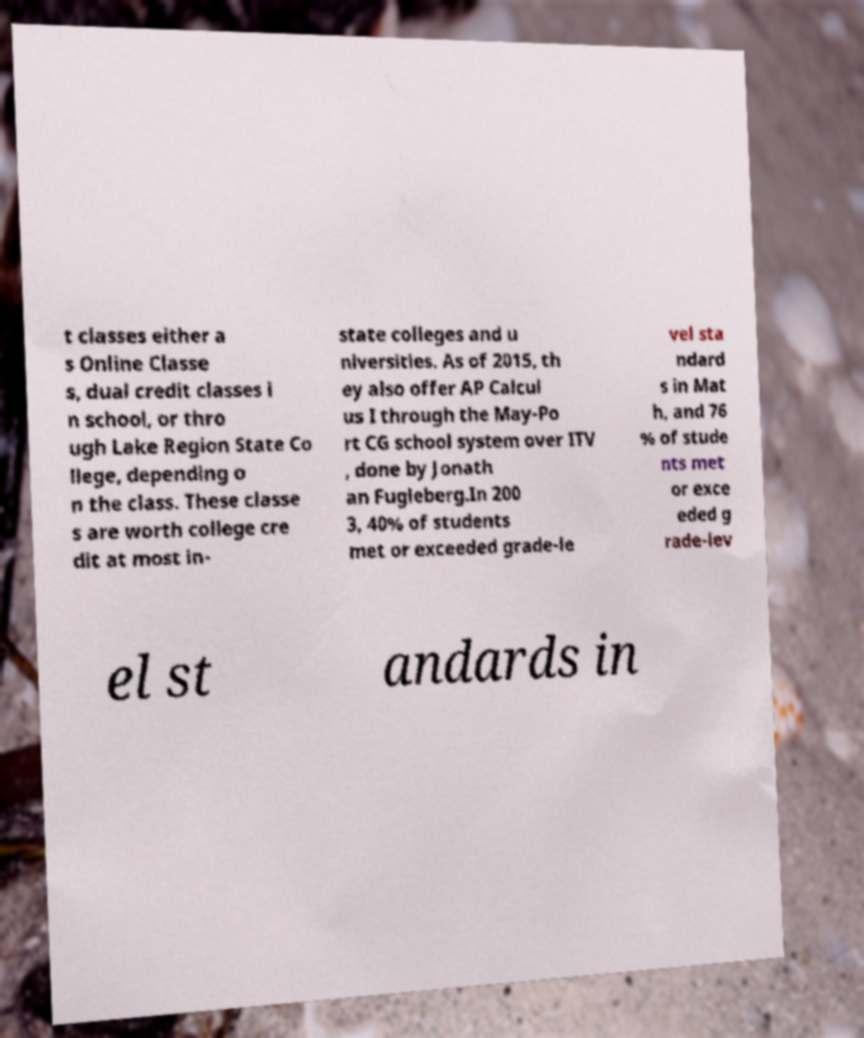Could you assist in decoding the text presented in this image and type it out clearly? t classes either a s Online Classe s, dual credit classes i n school, or thro ugh Lake Region State Co llege, depending o n the class. These classe s are worth college cre dit at most in- state colleges and u niversities. As of 2015, th ey also offer AP Calcul us I through the May-Po rt CG school system over ITV , done by Jonath an Fugleberg.In 200 3, 40% of students met or exceeded grade-le vel sta ndard s in Mat h, and 76 % of stude nts met or exce eded g rade-lev el st andards in 